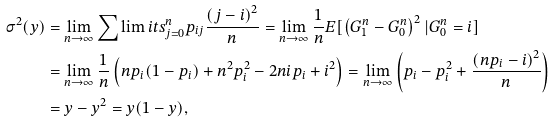<formula> <loc_0><loc_0><loc_500><loc_500>\sigma ^ { 2 } ( y ) & = \lim _ { n \to \infty } \sum \lim i t s _ { j = 0 } ^ { n } p _ { i j } \frac { \left ( j - i \right ) ^ { 2 } } { n } = \lim _ { n \to \infty } \frac { 1 } { n } E [ \left ( G ^ { n } _ { 1 } - G ^ { n } _ { 0 } \right ) ^ { 2 } | G ^ { n } _ { 0 } = i ] \\ & = \lim _ { n \to \infty } \frac { 1 } { n } \left ( n p _ { i } ( 1 - p _ { i } ) + n ^ { 2 } p ^ { 2 } _ { i } - 2 n i p _ { i } + i ^ { 2 } \right ) = \lim _ { n \to \infty } \left ( p _ { i } - p ^ { 2 } _ { i } + \frac { \left ( n p _ { i } - i \right ) ^ { 2 } } { n } \right ) \\ & = y - y ^ { 2 } = y ( 1 - y ) ,</formula> 